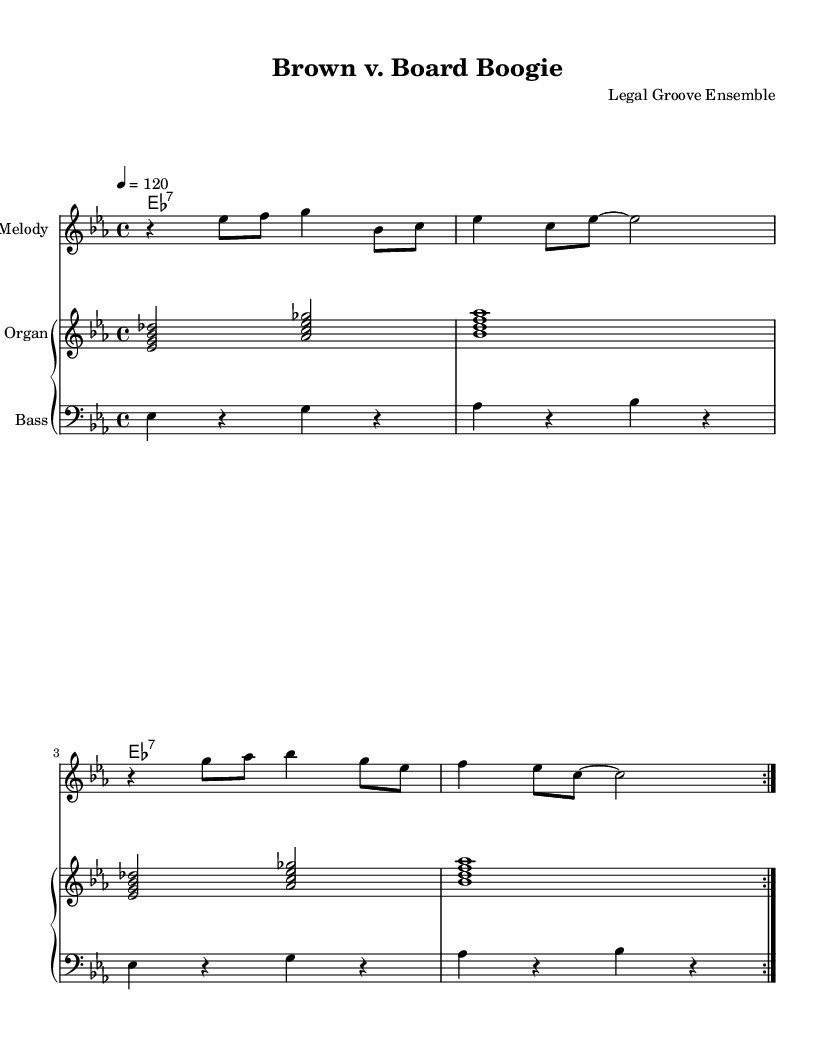What is the key signature of this music? The key signature is indicated by the presence of three flats (B♭, E♭, and A♭) in the staff, which corresponds to E♭ major or C minor. Upon examination, the music is in E♭ major, as it is played in a major scale context.
Answer: E♭ major What is the time signature of this piece? The time signature is represented in the beginning, shown as a fraction, where the top number indicates the number of beats in a measure (4), and the bottom number indicates the kind of note that gets one beat (4 represents a quarter note). Thus, this piece is in 4/4 time.
Answer: 4/4 What is the tempo marking of the music? The tempo marking is located above the staff at the beginning of the score, indicated by "4 = 120," which specifies the beat per minute. The number indicates the speed at which the quarter note should be played, establishing a lively tempo.
Answer: 120 How many repetitions does the melody section have? The melody section features a "repeat volta 2" marking, suggesting that the melody will be played two times, resulting in a total of two repetitions, as indicated by the symbol.
Answer: 2 What is the role of the bass line in this funk piece? The bass line, written in the bass clef, plays a fundamental role by providing the rhythmic and harmonic foundation for the groove typical in funk music. The use of rhythmic rests and syncopation in this line contributes to the overall funky feel.
Answer: Groovy foundation What chord is primarily used in the guitar section? The guitar part predominantly features the E♭7 chord (written as "es1:7"), which is played consistently throughout, emphasizing a characteristic dominant 7th sound typical in funk music.
Answer: E♭7 How does the organ part complement the melody? The organ part consists of chords that support the melody and add harmonic richness. The use of seventh chords and the rhythmic pattern of beats complement the melody, enhancing the funk groove and creating a fuller sound.
Answer: Adds harmonic richness 